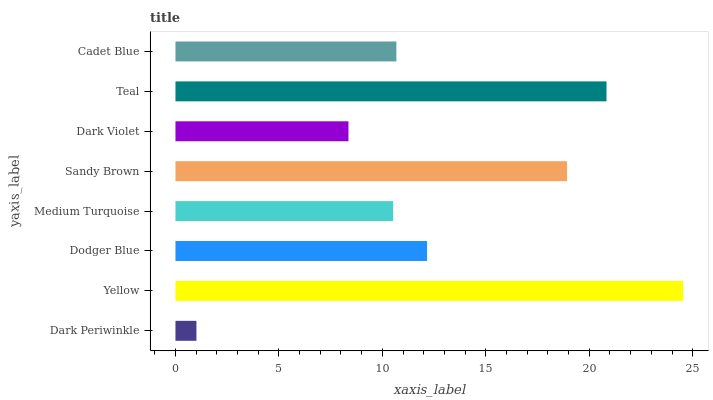Is Dark Periwinkle the minimum?
Answer yes or no. Yes. Is Yellow the maximum?
Answer yes or no. Yes. Is Dodger Blue the minimum?
Answer yes or no. No. Is Dodger Blue the maximum?
Answer yes or no. No. Is Yellow greater than Dodger Blue?
Answer yes or no. Yes. Is Dodger Blue less than Yellow?
Answer yes or no. Yes. Is Dodger Blue greater than Yellow?
Answer yes or no. No. Is Yellow less than Dodger Blue?
Answer yes or no. No. Is Dodger Blue the high median?
Answer yes or no. Yes. Is Cadet Blue the low median?
Answer yes or no. Yes. Is Dark Periwinkle the high median?
Answer yes or no. No. Is Dark Violet the low median?
Answer yes or no. No. 